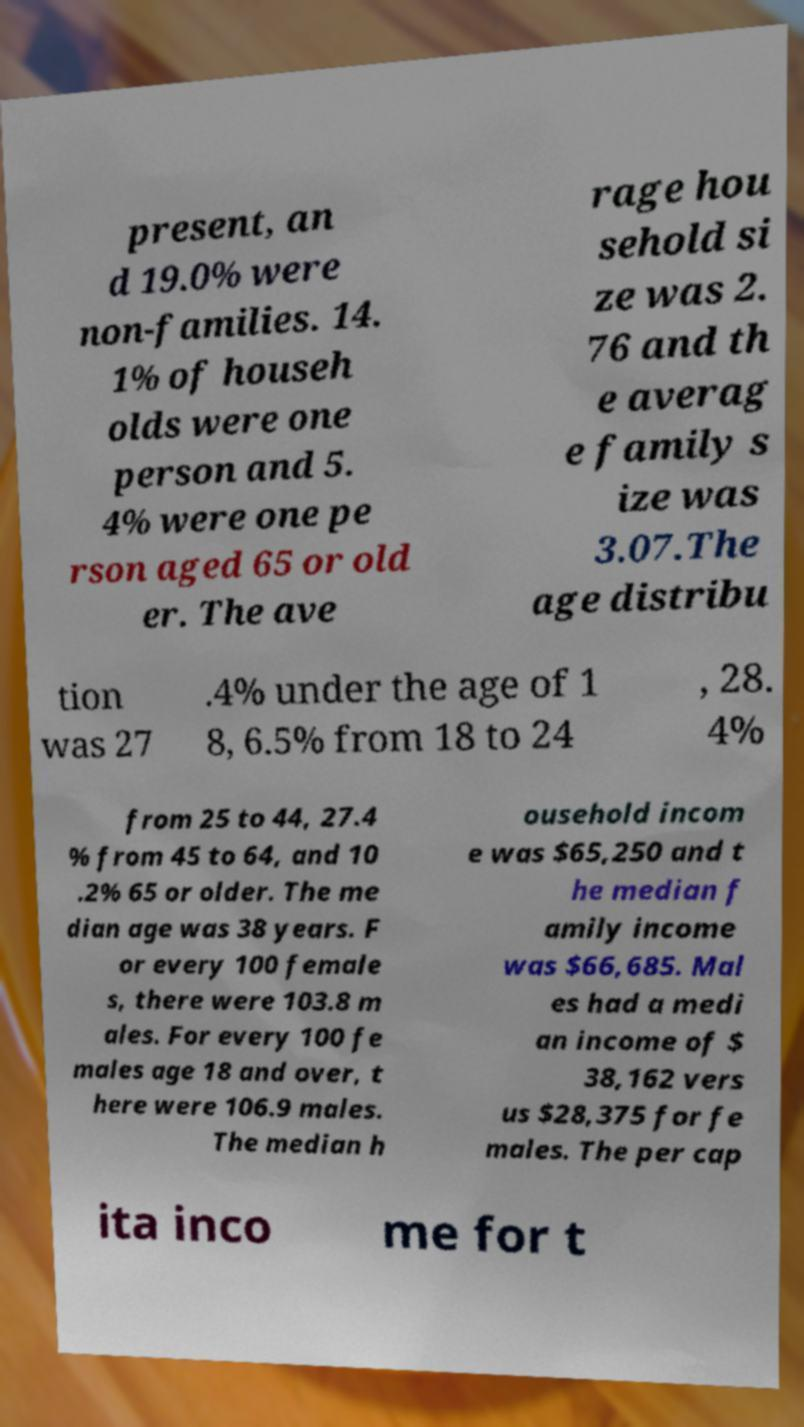For documentation purposes, I need the text within this image transcribed. Could you provide that? present, an d 19.0% were non-families. 14. 1% of househ olds were one person and 5. 4% were one pe rson aged 65 or old er. The ave rage hou sehold si ze was 2. 76 and th e averag e family s ize was 3.07.The age distribu tion was 27 .4% under the age of 1 8, 6.5% from 18 to 24 , 28. 4% from 25 to 44, 27.4 % from 45 to 64, and 10 .2% 65 or older. The me dian age was 38 years. F or every 100 female s, there were 103.8 m ales. For every 100 fe males age 18 and over, t here were 106.9 males. The median h ousehold incom e was $65,250 and t he median f amily income was $66,685. Mal es had a medi an income of $ 38,162 vers us $28,375 for fe males. The per cap ita inco me for t 